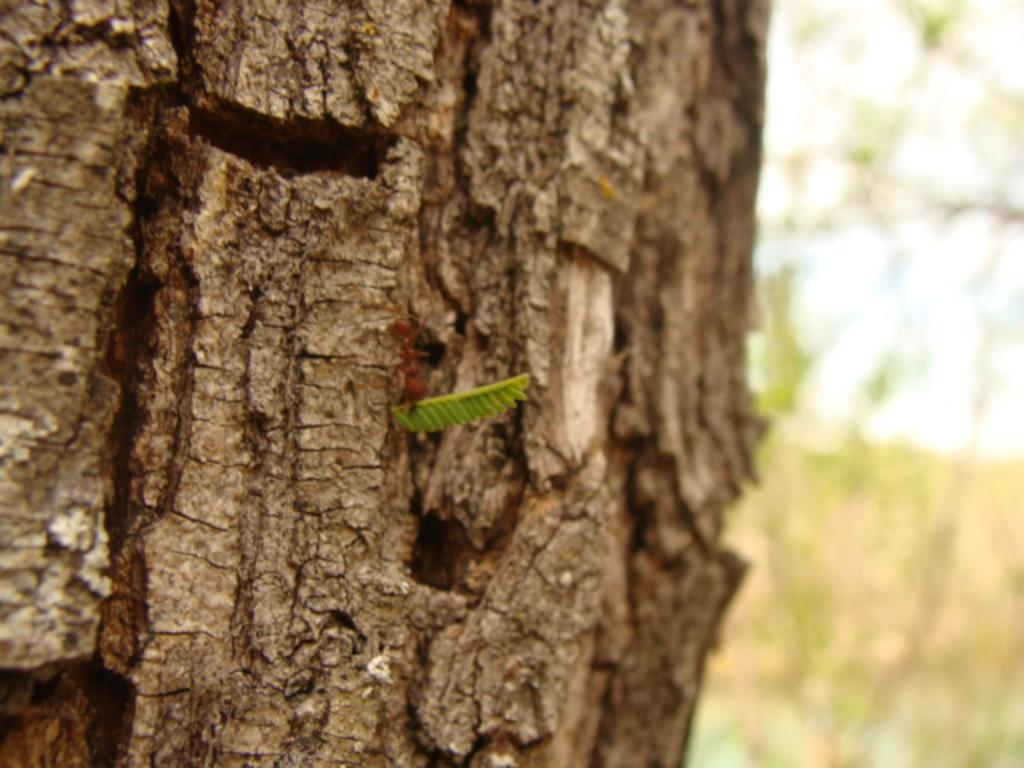What is the main subject of the image? There is a tree in the image. Can you describe the colors of the tree? The tree has brown and green colors. What can be seen in the background of the image? The background of the image is blurry, and there are trees and the sky visible. How many mice are sitting on the branches of the tree in the image? There are no mice present in the image; it only features a tree with brown and green colors. What is the weight of the tiger visible in the image? There is no tiger present in the image; it only features a tree with brown and green colors. 